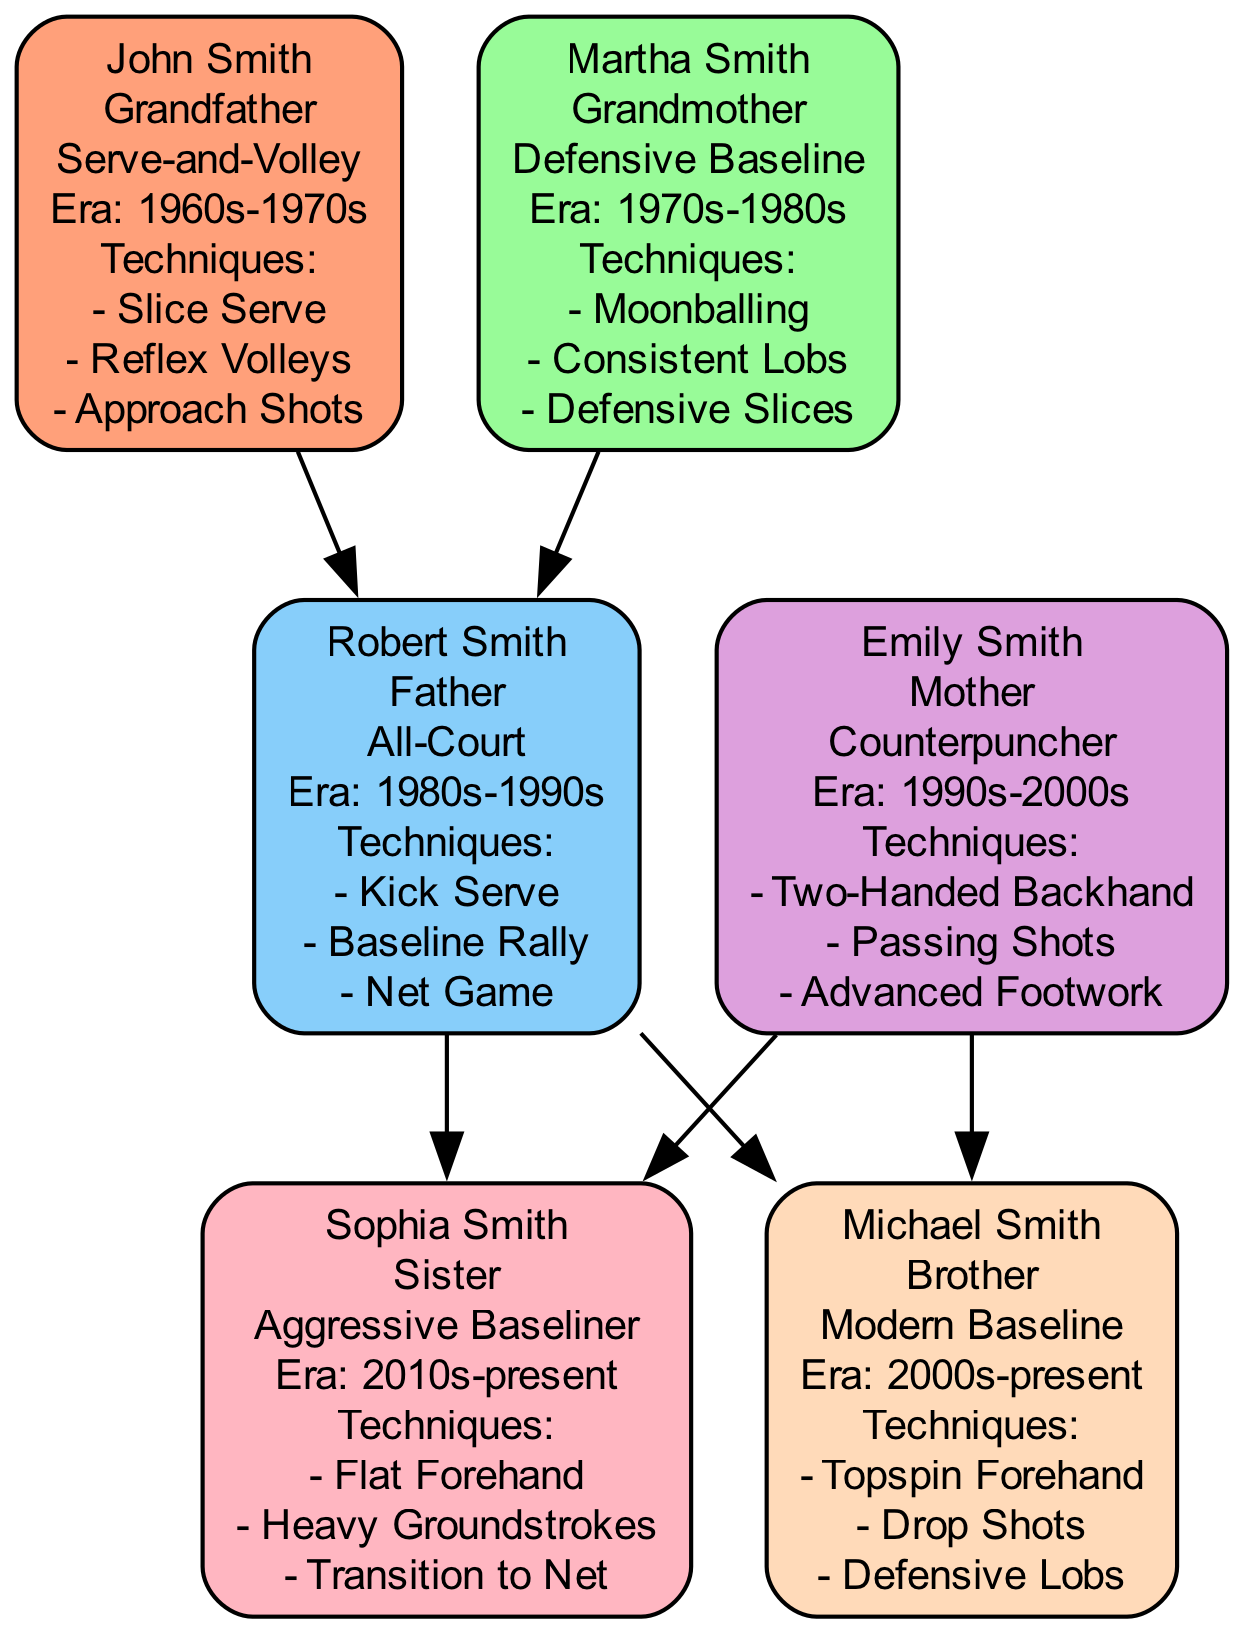What is the playing style of John Smith? The diagram shows that John Smith's playing style is listed clearly. He is labeled with the text "Serve-and-Volley" underneath his name.
Answer: Serve-and-Volley How many techniques mastered does Emily Smith have? By examining Emily Smith's section in the diagram, we can see that she has three techniques listed: "Two-Handed Backhand," "Passing Shots," and "Advanced Footwork." Therefore, she has a total of three techniques mastered.
Answer: 3 Who is the mother of Michael Smith? To answer this, we look at the connections in the family tree. Michael Smith is connected to Emily Smith, who is labeled as "Mother," indicating that she is Michael's mother.
Answer: Emily Smith What era did Robert Smith play in? In the diagram, Robert Smith's era is stated as "1980s-1990s," which provides a clear timeframe in which he played.
Answer: 1980s-1990s Which family member has a playing style of "Aggressive Baseliner"? Reviewing the family members listed, Sophia Smith is identified under "Sister" and her playing style is clearly labeled as "Aggressive Baseliner."
Answer: Sophia Smith How many family members are represented in the diagram? Counting the distinct family members displayed in the diagram—John Smith, Martha Smith, Robert Smith, Emily Smith, Sophia Smith, and Michael Smith—we find there are a total of six family members represented.
Answer: 6 Which playing style is associated with the relationship of "Grandmother"? Looking at the diagram, Martha Smith is labeled as "Grandmother," and her playing style is indicated as "Defensive Baseline," which is the answer to this question.
Answer: Defensive Baseline What is the relationship between Robert Smith and Sophia Smith? In the diagram, Sophia Smith is connected to Robert Smith as his daughter, which establishes that their relationship is that of father and daughter.
Answer: Father-Daughter What technique did John Smith master that is also used in a serve? The techniques listed under John Smith include "Slice Serve," which is specifically related to serving in tennis, making it a direct technique.
Answer: Slice Serve 